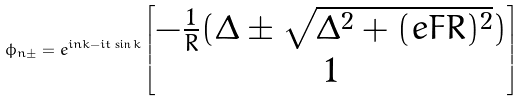<formula> <loc_0><loc_0><loc_500><loc_500>\phi _ { n \pm } = e ^ { i n k - i t \sin k } \begin{bmatrix} - \frac { 1 } { R } ( \Delta \pm \sqrt { \Delta ^ { 2 } + ( e F R ) ^ { 2 } } ) \\ 1 \end{bmatrix}</formula> 